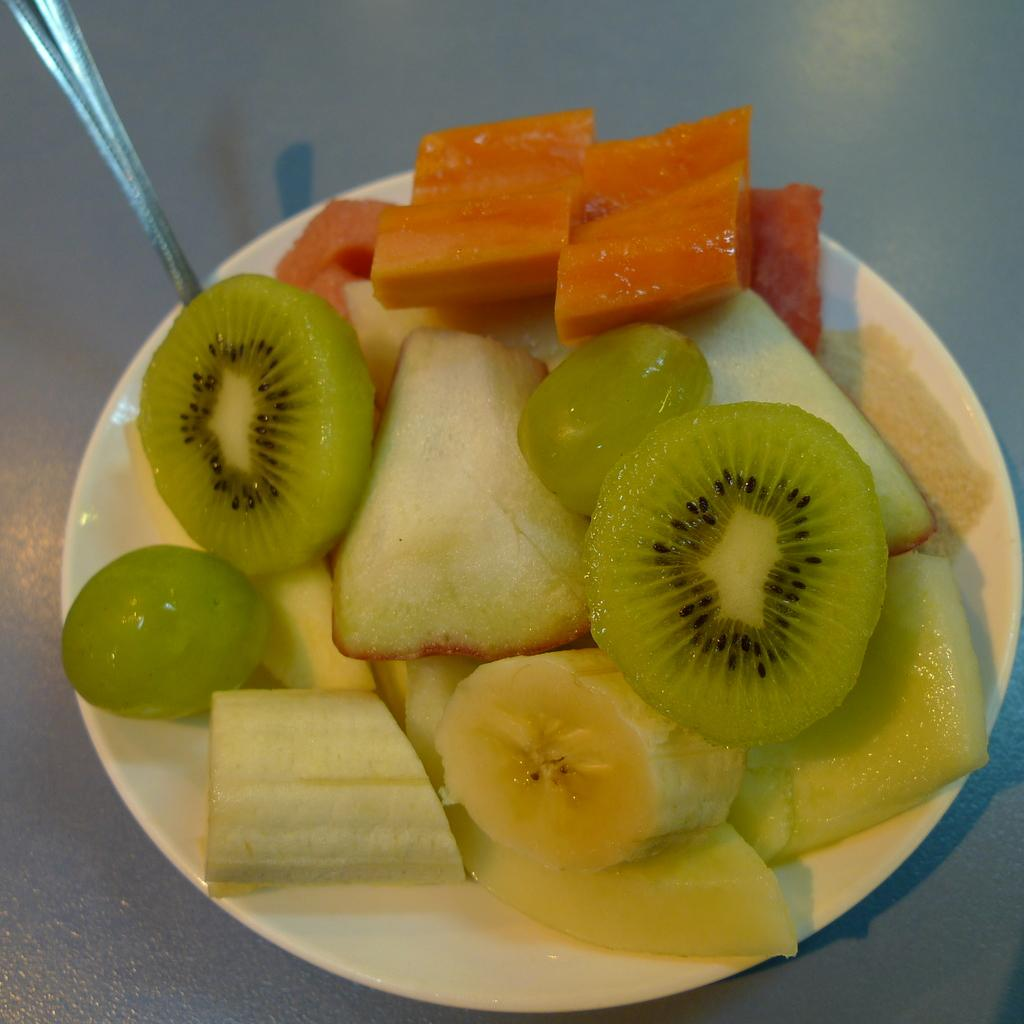What type of food can be seen in the image? There are cut fruits in the image. What is the color of the plate on which the cut fruits are placed? The cut fruits are on a white plate. What utensil is present in the image? There is a spoon in the image. On what surface are the cut fruits and spoon placed? The objects are placed on a surface. What type of clam is being cooked on the surface in the image? There is no clam or cooking activity present in the image; it features cut fruits on a white plate with a spoon. 